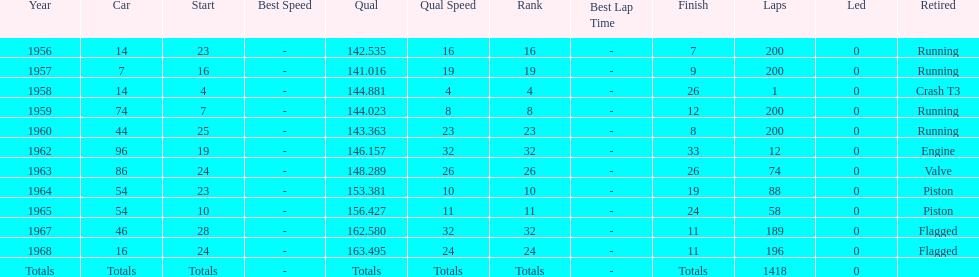What was its best starting position? 4. 